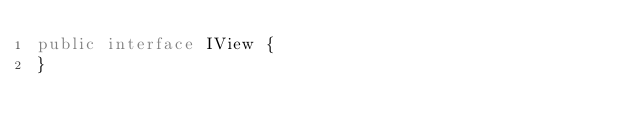<code> <loc_0><loc_0><loc_500><loc_500><_Java_>public interface IView {
}
</code> 